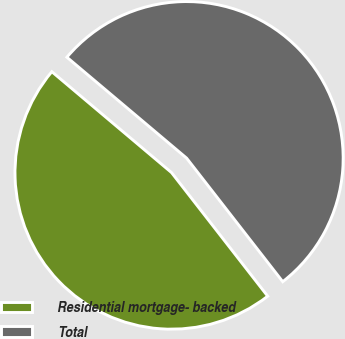<chart> <loc_0><loc_0><loc_500><loc_500><pie_chart><fcel>Residential mortgage- backed<fcel>Total<nl><fcel>46.67%<fcel>53.33%<nl></chart> 